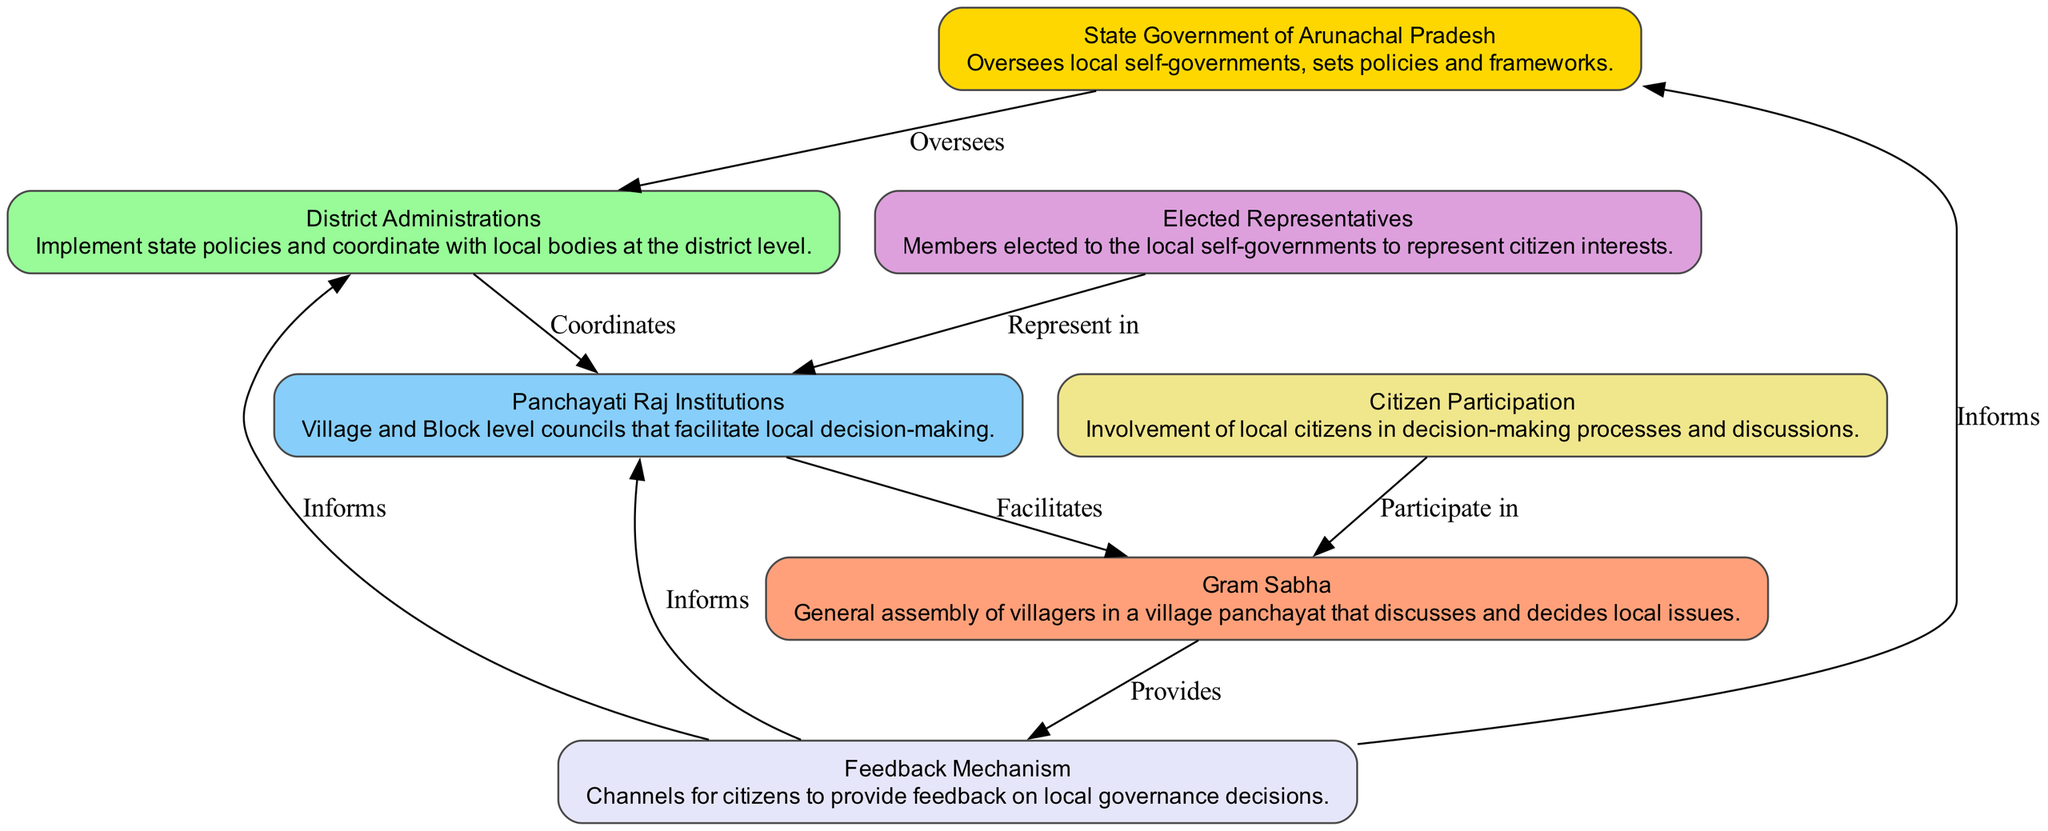What is the topmost node in the diagram? The topmost node in the diagram represents the State Government of Arunachal Pradesh, which oversees the local self-governments.
Answer: State Government of Arunachal Pradesh How many nodes are there in the diagram? There are a total of seven nodes representing different elements within the local self-government structure.
Answer: 7 What relationship exists between the District Administrations and Panchayati Raj Institutions? The relationship is depicted as "Coordinates", indicating that District Administrations coordinate with local bodies such as Panchayati Raj Institutions.
Answer: Coordinates Which node represents citizen involvement in decision-making? The node that represents citizen involvement is "Citizen Participation", highlighting the importance of local citizens in the decision-making processes.
Answer: Citizen Participation How does the Gram Sabha interact with the Feedback Mechanism? The Gram Sabha "Provides" feedback to the Feedback Mechanism, which facilitates communication between citizens and governance.
Answer: Provides What is the function of the Elected Representatives in the local self-government? The function of the Elected Representatives is to "Represent in" the Panchayati Raj Institutions, ensuring that citizen interests are voiced at the local level.
Answer: Represent in Which node informs both the Panchayati Raj Institutions and District Administrations? The Feedback Mechanism informs both the Panchayati Raj Institutions and District Administrations, indicating it serves as a channel of communication.
Answer: Informs What does the diagonal flow from Citizen Participation to Gram Sabha signify? This flow shows that citizens "Participate in" the discussions and decision-making processes within the Gram Sabha.
Answer: Participate in 